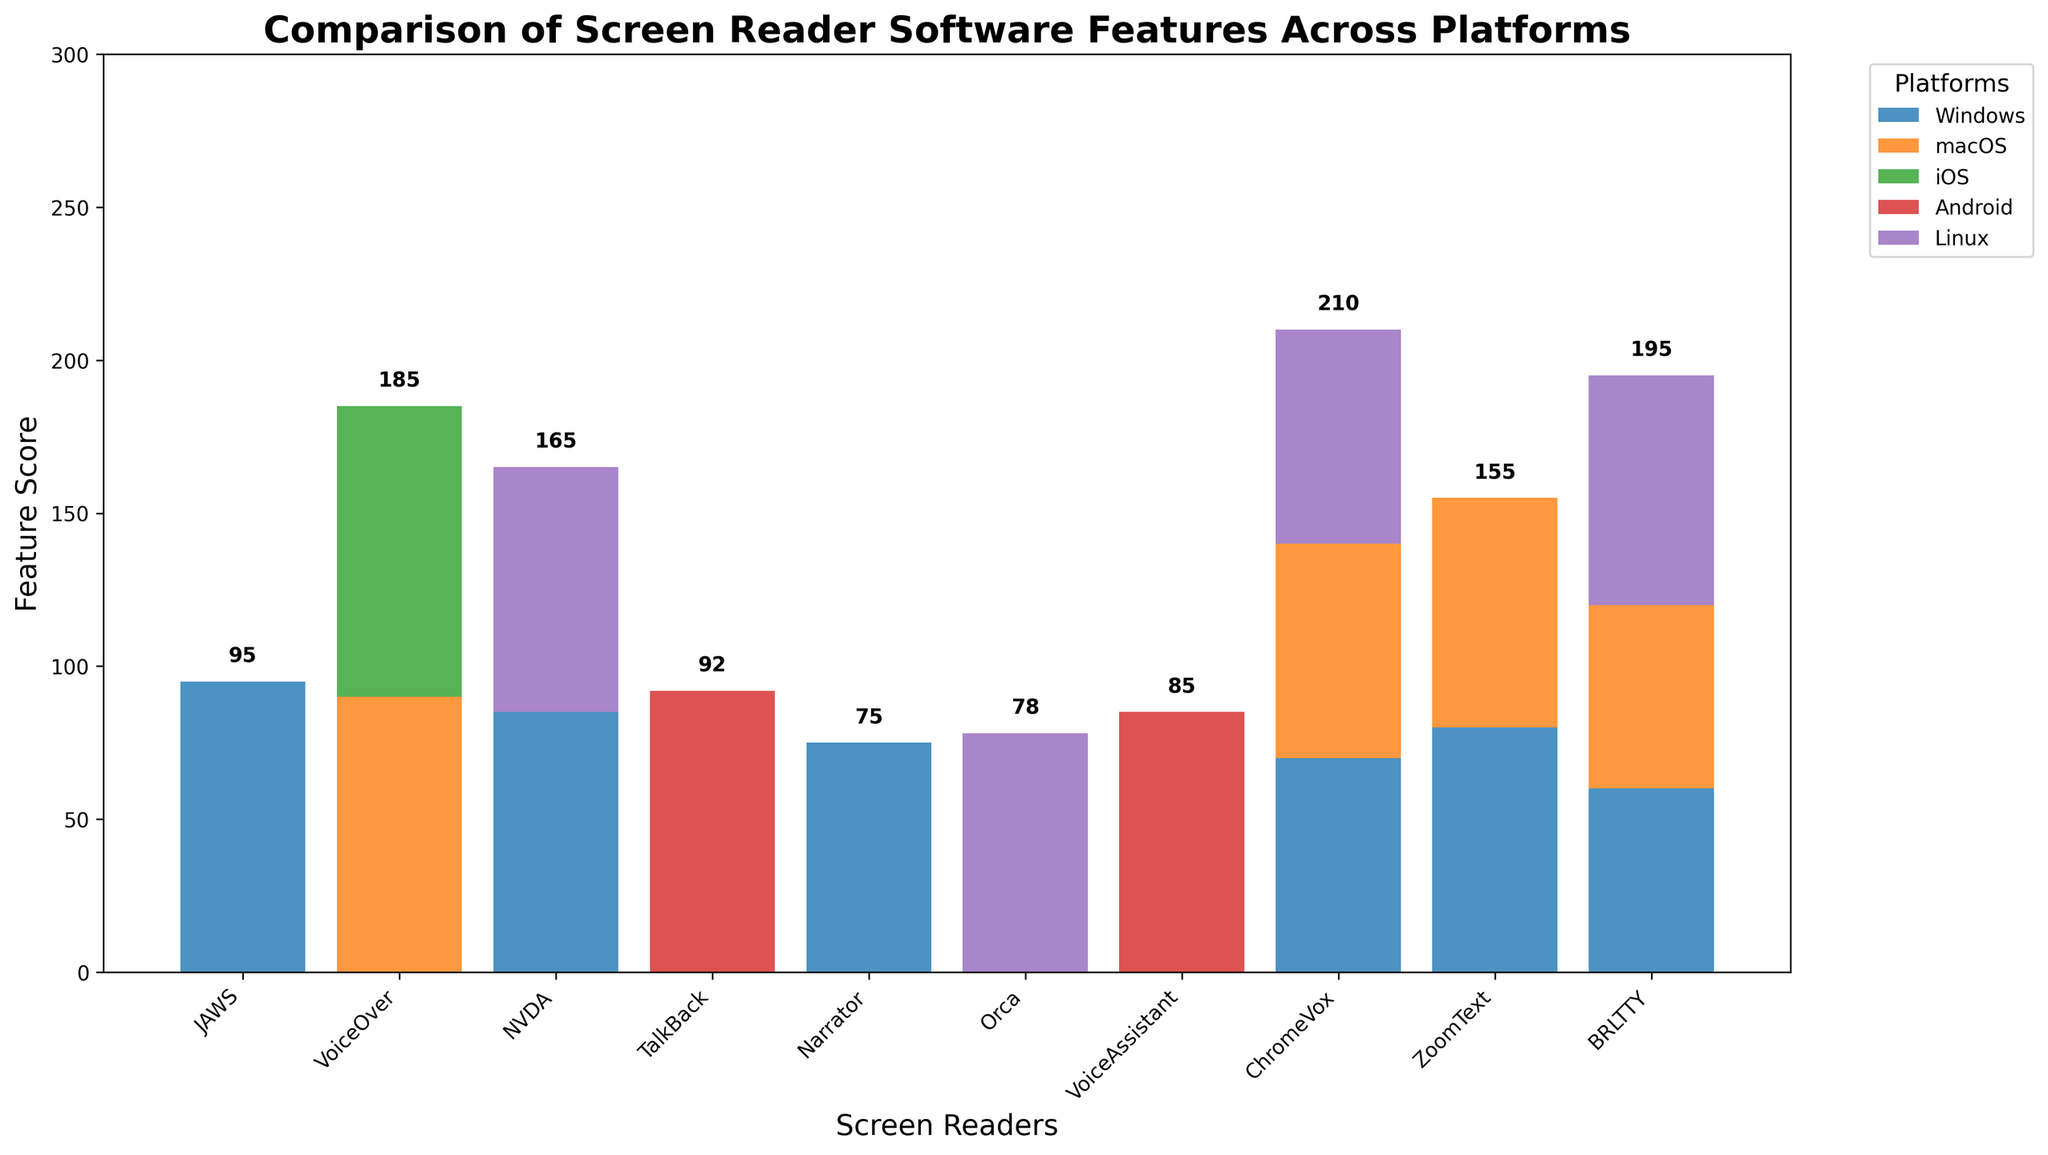Which screen reader scores the highest on Windows? Looking at the bars representing Windows, the tallest bar is JAWS, which reaches the top score of 95.
Answer: JAWS Which screen readers are supported on both Windows and macOS? Observing the bars under both the Windows and macOS groups, ChromeVox and BRLTTY bars appear in both columns.
Answer: ChromeVox, BRLTTY What is the total feature score for JAWS across all platforms? Only the Windows platform has a score for JAWS. The height of the bar for JAWS under Windows is 95. Adding the scores across all platforms (95 + 0 + 0 + 0 + 0) gives a total of 95.
Answer: 95 How does the feature score of VoiceOver on macOS compare to its score on iOS? The bar for VoiceOver on macOS reaches 90, while the iOS bar reaches 95. Comparing the heights, VoiceOver scores higher on iOS than on macOS.
Answer: iOS higher Which screen reader has the highest combined score for Linux and another platform of your choice? Observing the bars under the Linux column, NVDA and BRLTTY have bars. Breaking them down, NVDA (80 on Linux), and adding the score from another platform e.g. Windows (85) total is 165. BRLTTY has a combined 60 (Windows) + 75 (Linux) = 135. NVDA has the highest combined score.
Answer: NVDA What is the difference in total scores between ChromeVox on Windows and macOS combined versus VoiceOver on macOS and iOS combined? Adding scores for ChromeVox: Windows (70) + macOS (70) = 140. For VoiceOver: macOS (90) + iOS (95) = 185. The difference between VoiceOver and ChromeVox combined scores is 185 - 140 = 45.
Answer: 45 